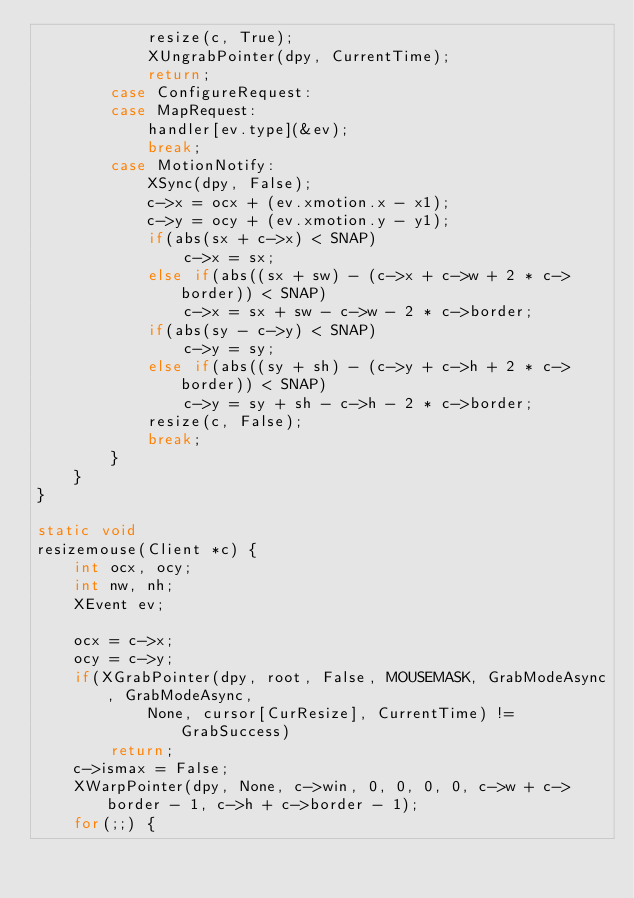Convert code to text. <code><loc_0><loc_0><loc_500><loc_500><_C_>            resize(c, True);
            XUngrabPointer(dpy, CurrentTime);
            return;
        case ConfigureRequest:
        case MapRequest:
            handler[ev.type](&ev);
            break;
        case MotionNotify:
            XSync(dpy, False);
            c->x = ocx + (ev.xmotion.x - x1);
            c->y = ocy + (ev.xmotion.y - y1);
            if(abs(sx + c->x) < SNAP)
                c->x = sx;
            else if(abs((sx + sw) - (c->x + c->w + 2 * c->border)) < SNAP)
                c->x = sx + sw - c->w - 2 * c->border;
            if(abs(sy - c->y) < SNAP)
                c->y = sy;
            else if(abs((sy + sh) - (c->y + c->h + 2 * c->border)) < SNAP)
                c->y = sy + sh - c->h - 2 * c->border;
            resize(c, False);
            break;
        }
    }
}

static void
resizemouse(Client *c) {
    int ocx, ocy;
    int nw, nh;
    XEvent ev;

    ocx = c->x;
    ocy = c->y;
    if(XGrabPointer(dpy, root, False, MOUSEMASK, GrabModeAsync, GrabModeAsync,
            None, cursor[CurResize], CurrentTime) != GrabSuccess)
        return;
    c->ismax = False;
    XWarpPointer(dpy, None, c->win, 0, 0, 0, 0, c->w + c->border - 1, c->h + c->border - 1);
    for(;;) {</code> 